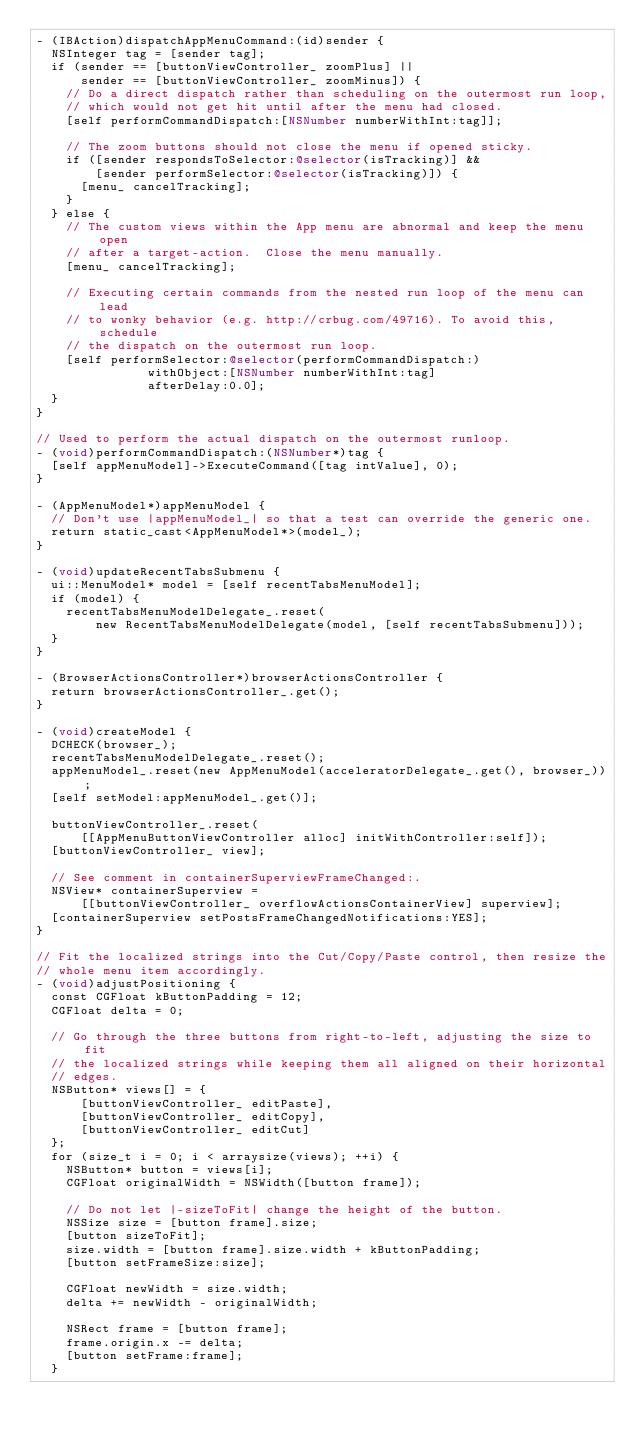Convert code to text. <code><loc_0><loc_0><loc_500><loc_500><_ObjectiveC_>- (IBAction)dispatchAppMenuCommand:(id)sender {
  NSInteger tag = [sender tag];
  if (sender == [buttonViewController_ zoomPlus] ||
      sender == [buttonViewController_ zoomMinus]) {
    // Do a direct dispatch rather than scheduling on the outermost run loop,
    // which would not get hit until after the menu had closed.
    [self performCommandDispatch:[NSNumber numberWithInt:tag]];

    // The zoom buttons should not close the menu if opened sticky.
    if ([sender respondsToSelector:@selector(isTracking)] &&
        [sender performSelector:@selector(isTracking)]) {
      [menu_ cancelTracking];
    }
  } else {
    // The custom views within the App menu are abnormal and keep the menu open
    // after a target-action.  Close the menu manually.
    [menu_ cancelTracking];

    // Executing certain commands from the nested run loop of the menu can lead
    // to wonky behavior (e.g. http://crbug.com/49716). To avoid this, schedule
    // the dispatch on the outermost run loop.
    [self performSelector:@selector(performCommandDispatch:)
               withObject:[NSNumber numberWithInt:tag]
               afterDelay:0.0];
  }
}

// Used to perform the actual dispatch on the outermost runloop.
- (void)performCommandDispatch:(NSNumber*)tag {
  [self appMenuModel]->ExecuteCommand([tag intValue], 0);
}

- (AppMenuModel*)appMenuModel {
  // Don't use |appMenuModel_| so that a test can override the generic one.
  return static_cast<AppMenuModel*>(model_);
}

- (void)updateRecentTabsSubmenu {
  ui::MenuModel* model = [self recentTabsMenuModel];
  if (model) {
    recentTabsMenuModelDelegate_.reset(
        new RecentTabsMenuModelDelegate(model, [self recentTabsSubmenu]));
  }
}

- (BrowserActionsController*)browserActionsController {
  return browserActionsController_.get();
}

- (void)createModel {
  DCHECK(browser_);
  recentTabsMenuModelDelegate_.reset();
  appMenuModel_.reset(new AppMenuModel(acceleratorDelegate_.get(), browser_));
  [self setModel:appMenuModel_.get()];

  buttonViewController_.reset(
      [[AppMenuButtonViewController alloc] initWithController:self]);
  [buttonViewController_ view];

  // See comment in containerSuperviewFrameChanged:.
  NSView* containerSuperview =
      [[buttonViewController_ overflowActionsContainerView] superview];
  [containerSuperview setPostsFrameChangedNotifications:YES];
}

// Fit the localized strings into the Cut/Copy/Paste control, then resize the
// whole menu item accordingly.
- (void)adjustPositioning {
  const CGFloat kButtonPadding = 12;
  CGFloat delta = 0;

  // Go through the three buttons from right-to-left, adjusting the size to fit
  // the localized strings while keeping them all aligned on their horizontal
  // edges.
  NSButton* views[] = {
      [buttonViewController_ editPaste],
      [buttonViewController_ editCopy],
      [buttonViewController_ editCut]
  };
  for (size_t i = 0; i < arraysize(views); ++i) {
    NSButton* button = views[i];
    CGFloat originalWidth = NSWidth([button frame]);

    // Do not let |-sizeToFit| change the height of the button.
    NSSize size = [button frame].size;
    [button sizeToFit];
    size.width = [button frame].size.width + kButtonPadding;
    [button setFrameSize:size];

    CGFloat newWidth = size.width;
    delta += newWidth - originalWidth;

    NSRect frame = [button frame];
    frame.origin.x -= delta;
    [button setFrame:frame];
  }
</code> 